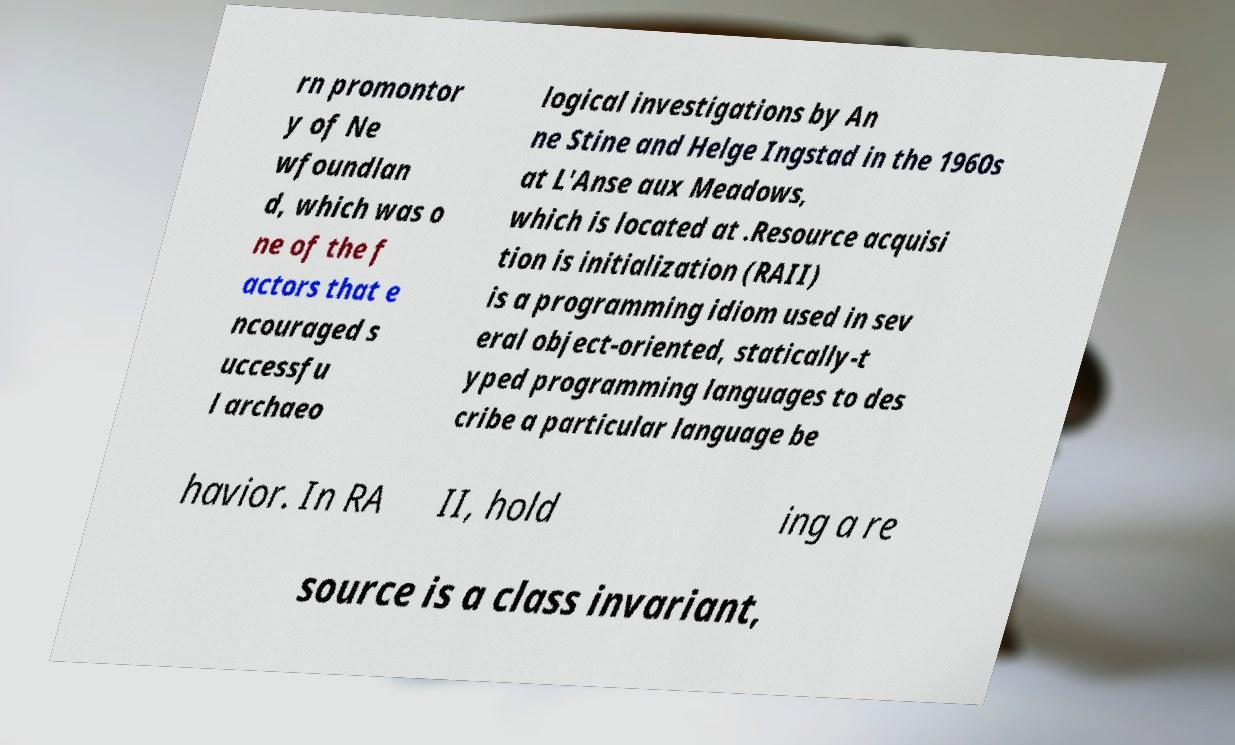I need the written content from this picture converted into text. Can you do that? rn promontor y of Ne wfoundlan d, which was o ne of the f actors that e ncouraged s uccessfu l archaeo logical investigations by An ne Stine and Helge Ingstad in the 1960s at L'Anse aux Meadows, which is located at .Resource acquisi tion is initialization (RAII) is a programming idiom used in sev eral object-oriented, statically-t yped programming languages to des cribe a particular language be havior. In RA II, hold ing a re source is a class invariant, 